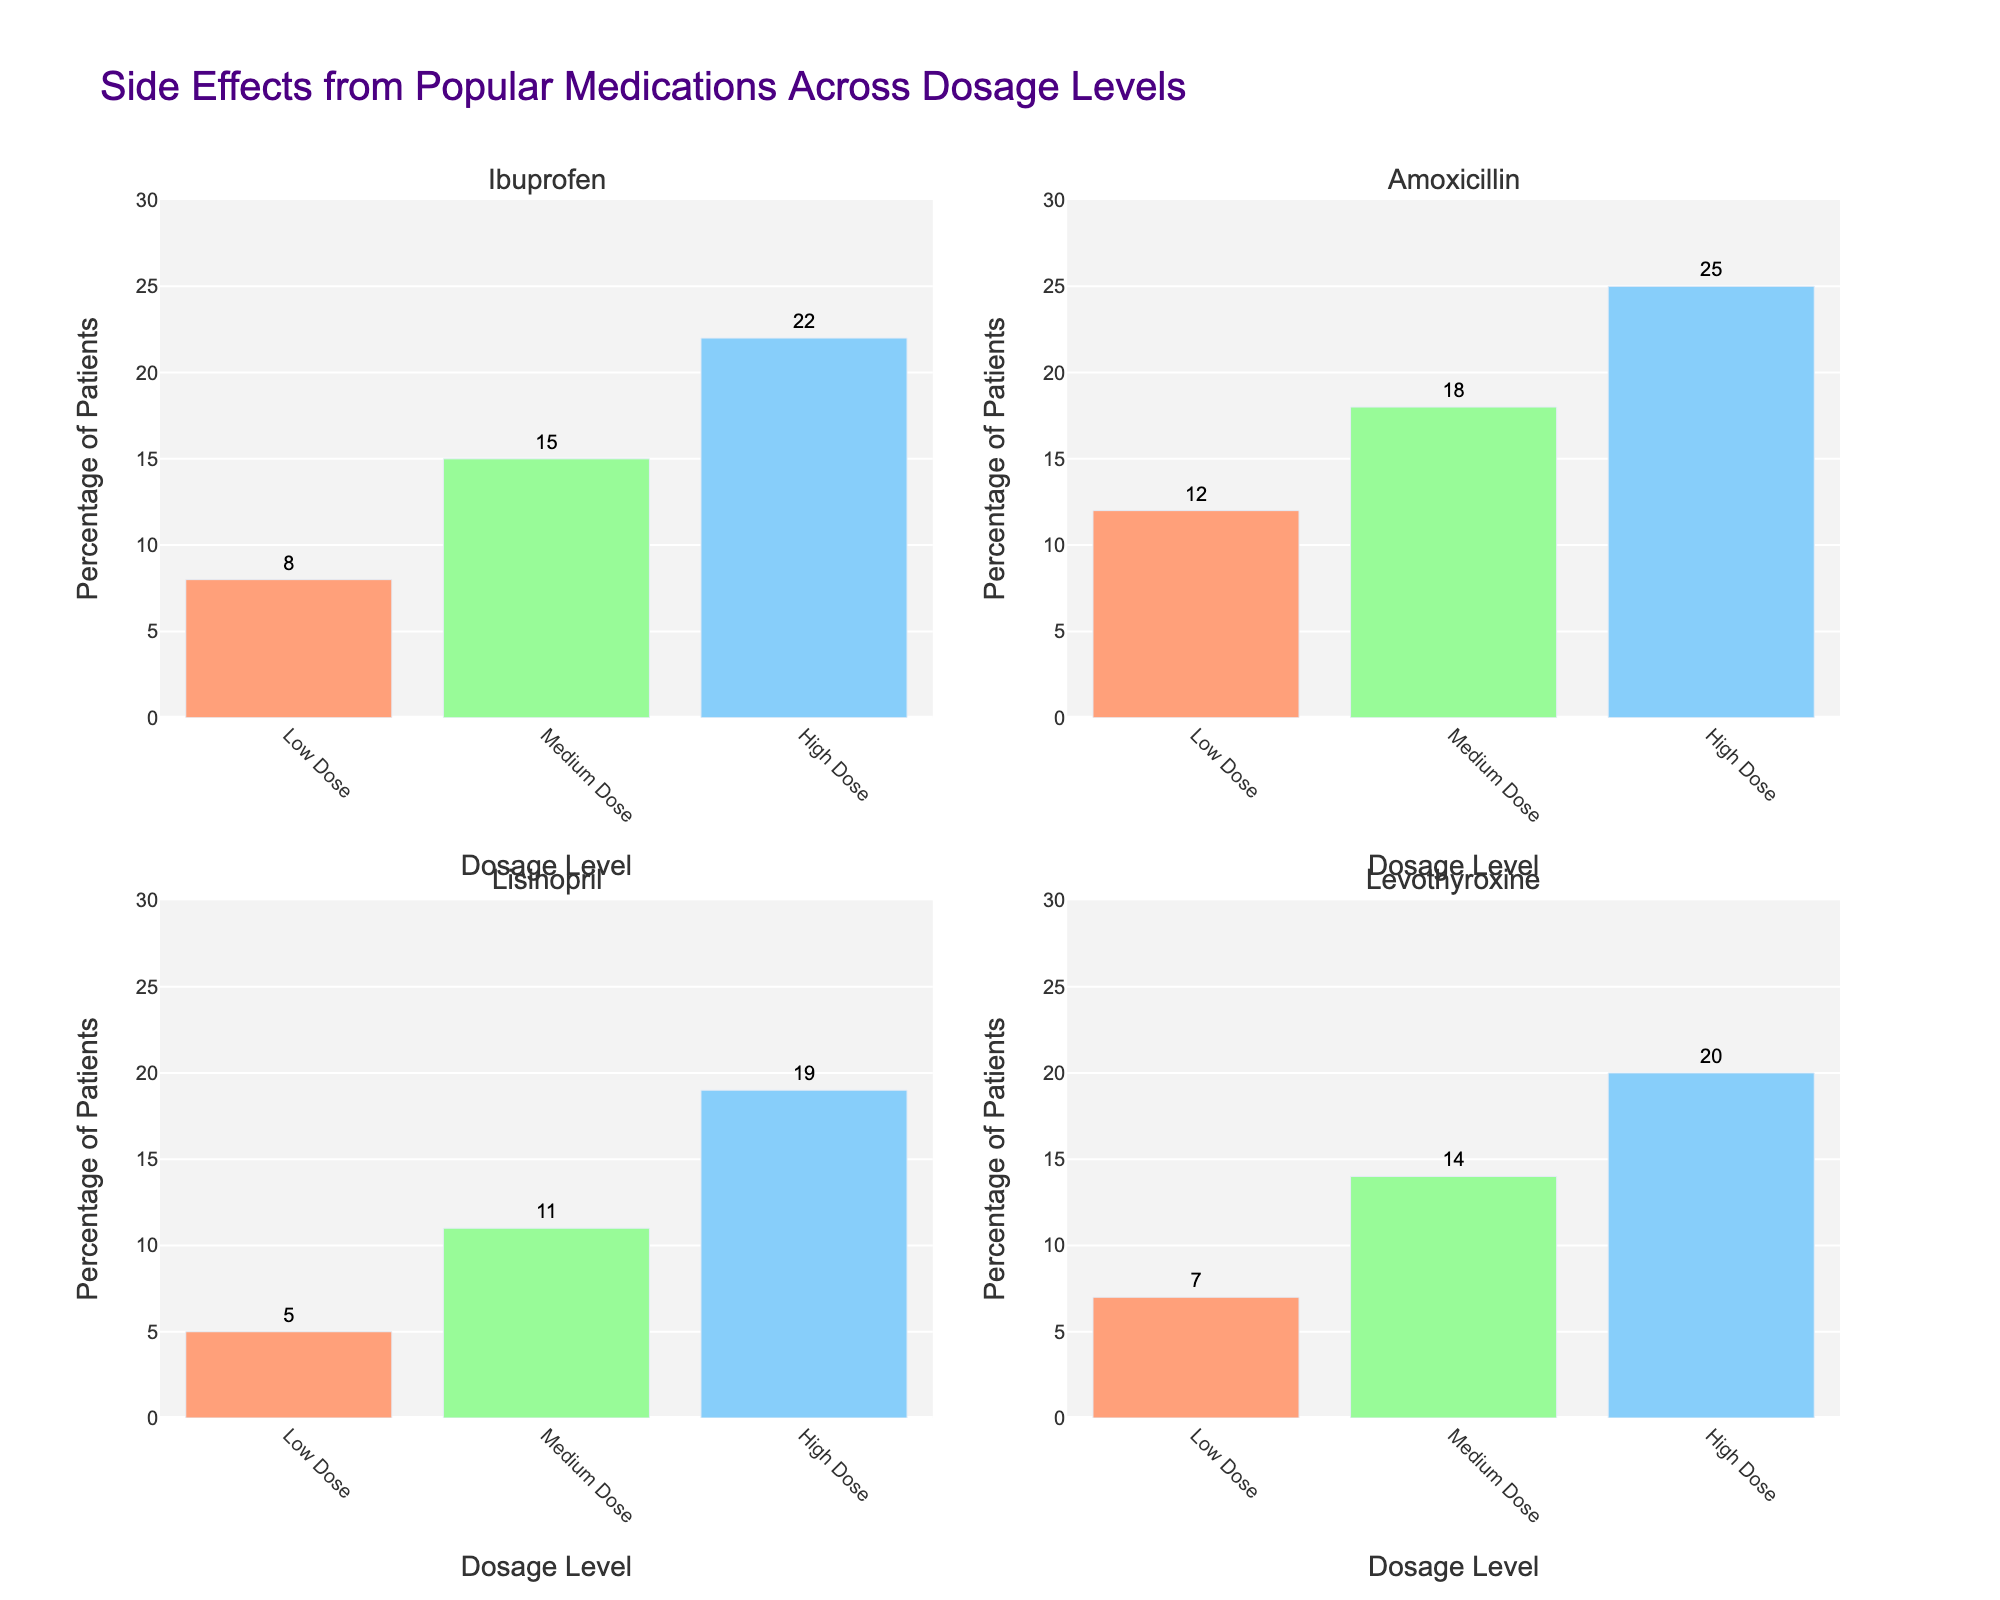What's the title of the figure? The title can be found at the top of the figure. It provides an overview of what the figure represents.
Answer: Side Effects from Popular Medications Across Dosage Levels Which medication has the highest percentage of patients experiencing side effects at the low dose level? Look at the heights of the bars under "Low Dose" for each medication in the first four subplots. The tallest bar indicates the highest percentage.
Answer: Amoxicillin How does the percentage of patients experiencing side effects at high dose level compare between Ibuprofen and Levothyroxine? Identify the bars for "High Dose" in the Ibuprofen and Levothyroxine subplots and compare their heights.
Answer: Ibuprofen has 22%, Levothyroxine has 20% What is the difference in the percentage of patients experiencing side effects between the medium and low doses for Sertraline? Find the bars representing "Medium Dose" and "Low Dose" for Sertraline and subtract the percentage of "Low Dose" from "Medium Dose".
Answer: 16% - 9% = 7% Which medication shows the smallest increase in side effects from low dose to high dose? For each medication in the first four subplots, calculate the increase in percentage from the "Low Dose" to "High Dose". The smallest increase indicates the answer.
Answer: Lisinopril What's the average percentage of patients experiencing side effects from all dosage levels for Metformin? Find the bars representing Metformin in all dosage levels, sum up the percentages, and divide by the number of dosage levels (3).
Answer: (10 + 17 + 24) / 3 = 17% What is the combined percentage of patients experiencing side effects at medium and high doses for Omeprazole? Identify the bars representing "Medium Dose" and "High Dose" for Omeprazole, sum their percentages.
Answer: 19% + 26% = 45% Among the first four medications, which one has the highest overall percentage of side effects across all dosage levels? Calculate the sum of percentages of side effects for all dosage levels for each of the first four medications and compare.
Answer: Omeprazole Compare the trend of side effects across dosage levels between Ibuprofen and Atorvastatin. Observe the change in bar heights for each dosage level (Low, Medium, High) for Ibuprofen and Atorvastatin and describe the patterns.
Answer: Both show increasing side effects with increasing dosage, but Atorvastatin starts lower and increases more steadily What is the range of percentages of patients experiencing side effects for Levothyroxine across all dosage levels? For Levothyroxine, identify the minimum and maximum percentages from the bars representing all dosage levels, and subtract the smallest from the largest.
Answer: 20% - 7% = 13% 